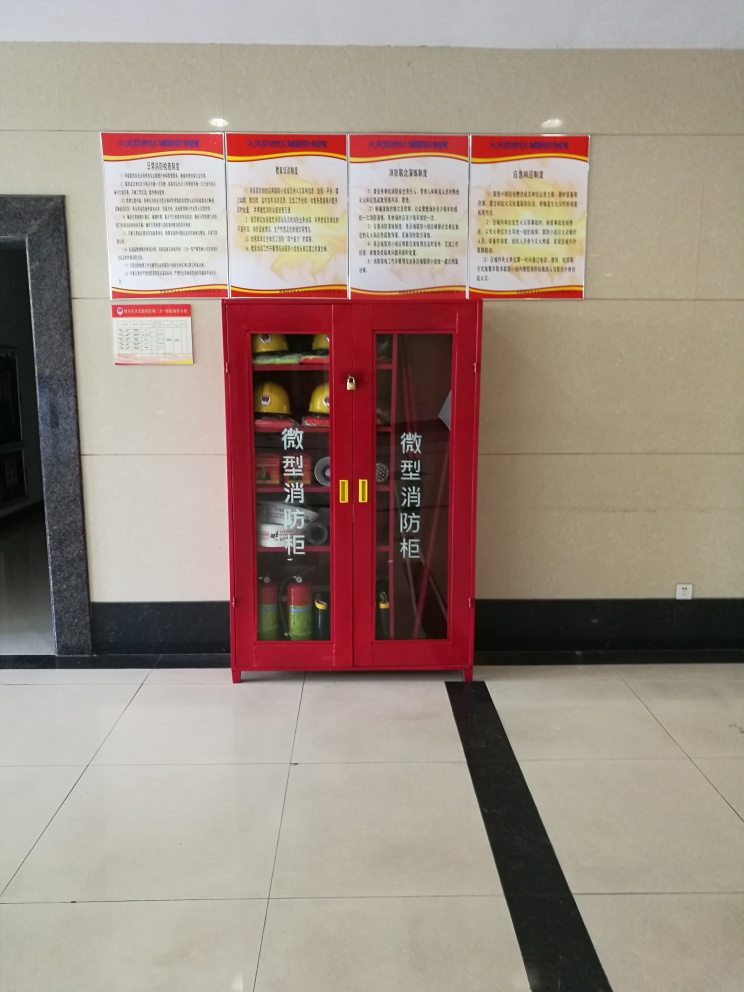What can you tell me about the items contained in this cabinet? The red cabinet shown in the image is a fire safety equipment cabinet commonly found in public places. Inside, there are fire extinguishers and possibly other fire-fighting equipment such as hoses or emergency tools designed to be readily accessible in case of a fire. 